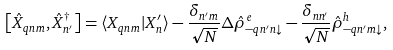Convert formula to latex. <formula><loc_0><loc_0><loc_500><loc_500>\left [ \hat { X } _ { { q } n m } , \hat { X } ^ { \dag } _ { n ^ { \prime } } \right ] = \langle X _ { { q } n m } | X _ { n } ^ { \prime } \rangle - \frac { \delta _ { n ^ { \prime } m } } { \sqrt { N } } \Delta \hat { \rho } _ { - { q } n ^ { \prime } n \downarrow } ^ { e } - \frac { \delta _ { n n ^ { \prime } } } { \sqrt { N } } \hat { \rho } _ { - { q } n ^ { \prime } m \downarrow } ^ { h } ,</formula> 